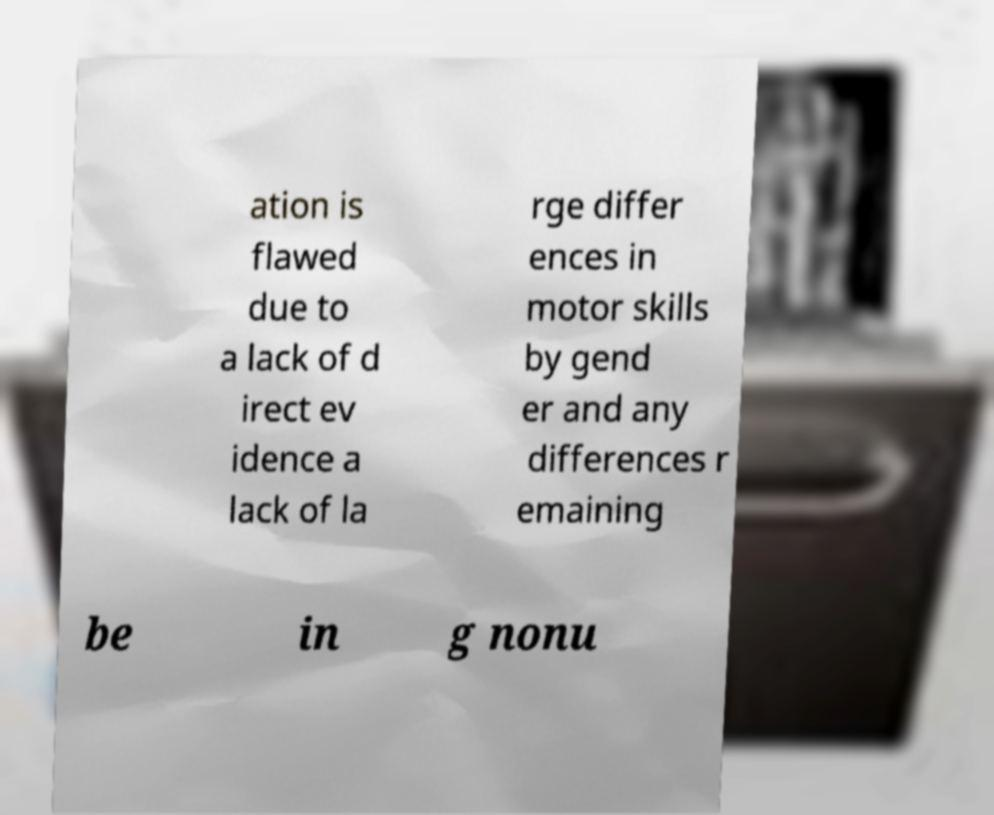Could you assist in decoding the text presented in this image and type it out clearly? ation is flawed due to a lack of d irect ev idence a lack of la rge differ ences in motor skills by gend er and any differences r emaining be in g nonu 